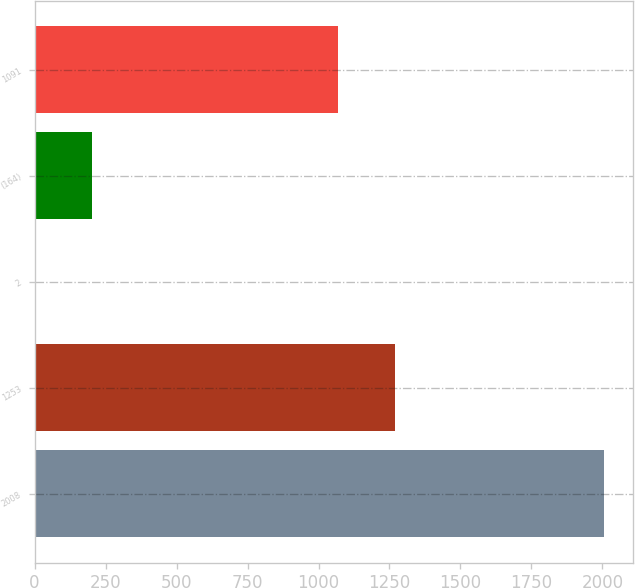<chart> <loc_0><loc_0><loc_500><loc_500><bar_chart><fcel>2008<fcel>1253<fcel>2<fcel>(164)<fcel>1091<nl><fcel>2006<fcel>1270.3<fcel>3<fcel>203.3<fcel>1070<nl></chart> 